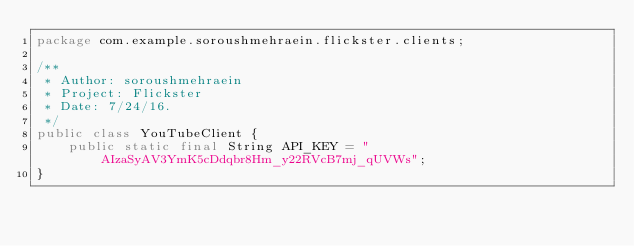Convert code to text. <code><loc_0><loc_0><loc_500><loc_500><_Java_>package com.example.soroushmehraein.flickster.clients;

/**
 * Author: soroushmehraein
 * Project: Flickster
 * Date: 7/24/16.
 */
public class YouTubeClient {
    public static final String API_KEY = "AIzaSyAV3YmK5cDdqbr8Hm_y22RVcB7mj_qUVWs";
}
</code> 